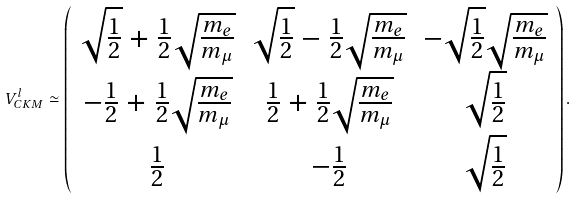<formula> <loc_0><loc_0><loc_500><loc_500>V _ { C K M } ^ { l } \simeq \left ( \begin{array} { c c c } { { \sqrt { \frac { 1 } { 2 } } + \frac { 1 } { 2 } \sqrt { \frac { m _ { e } } { m _ { \mu } } } } } & { { \sqrt { \frac { 1 } { 2 } } - \frac { 1 } { 2 } \sqrt { \frac { m _ { e } } { m _ { \mu } } } } } & { { - \sqrt { \frac { 1 } { 2 } } \sqrt { \frac { m _ { e } } { m _ { \mu } } } } } \\ { { - \frac { 1 } { 2 } + \frac { 1 } { 2 } \sqrt { \frac { m _ { e } } { m _ { \mu } } } } } & { { \frac { 1 } { 2 } + \frac { 1 } { 2 } \sqrt { \frac { m _ { e } } { m _ { \mu } } } } } & { { \sqrt { \frac { 1 } { 2 } } } } \\ { { \frac { 1 } { 2 } } } & { { - \frac { 1 } { 2 } } } & { { \sqrt { \frac { 1 } { 2 } } } } \end{array} \right ) .</formula> 